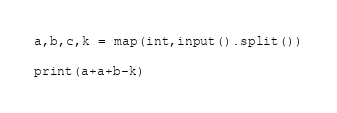<code> <loc_0><loc_0><loc_500><loc_500><_Python_>a,b,c,k = map(int,input().split())

print(a+a+b-k)</code> 